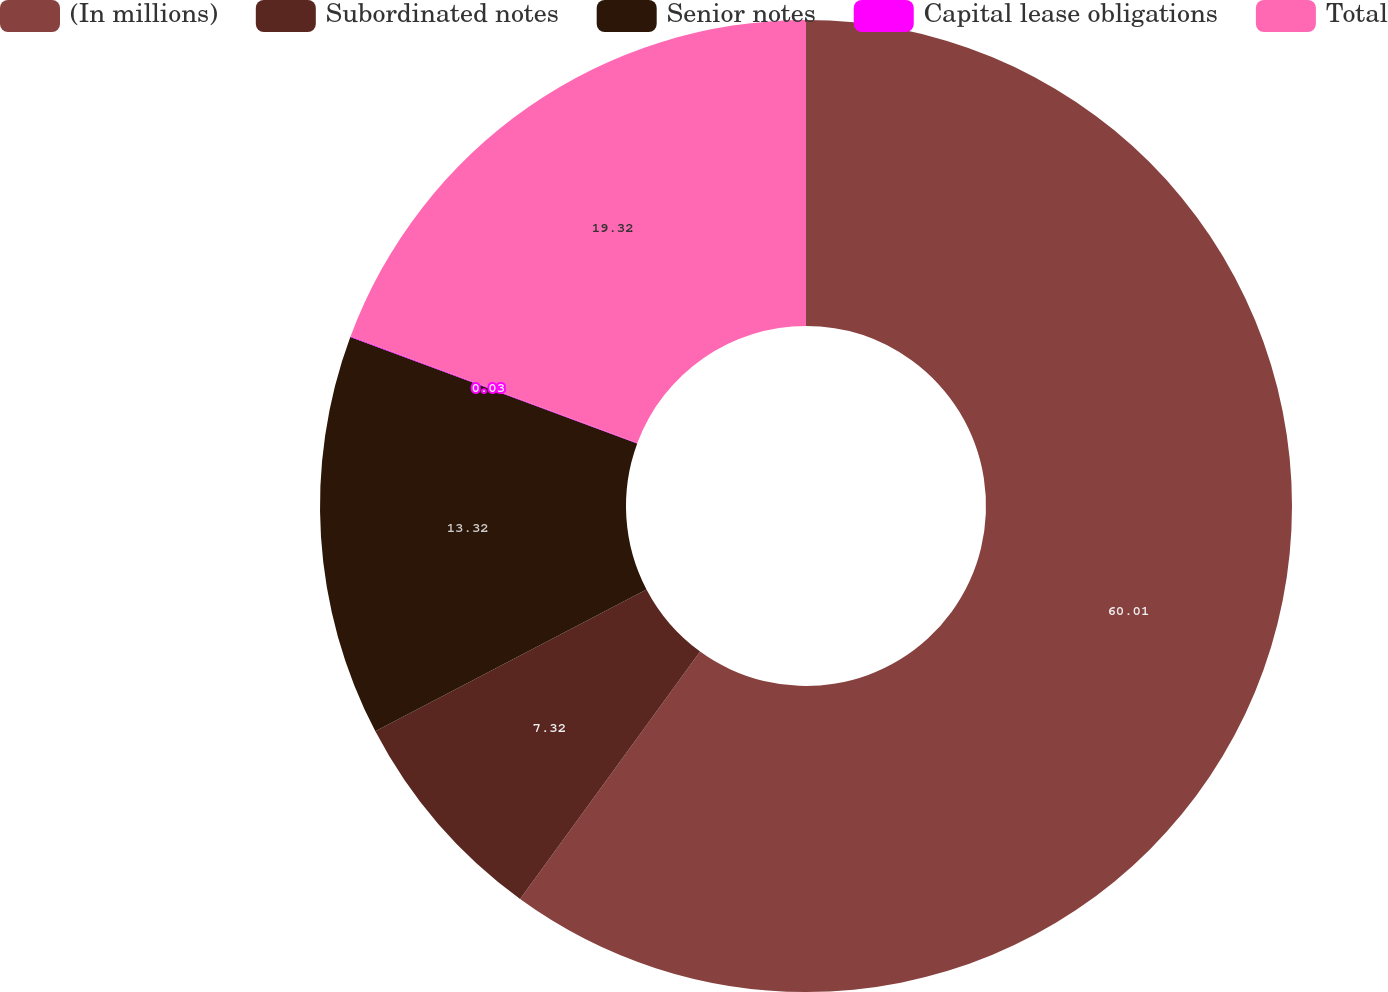<chart> <loc_0><loc_0><loc_500><loc_500><pie_chart><fcel>(In millions)<fcel>Subordinated notes<fcel>Senior notes<fcel>Capital lease obligations<fcel>Total<nl><fcel>60.01%<fcel>7.32%<fcel>13.32%<fcel>0.03%<fcel>19.32%<nl></chart> 